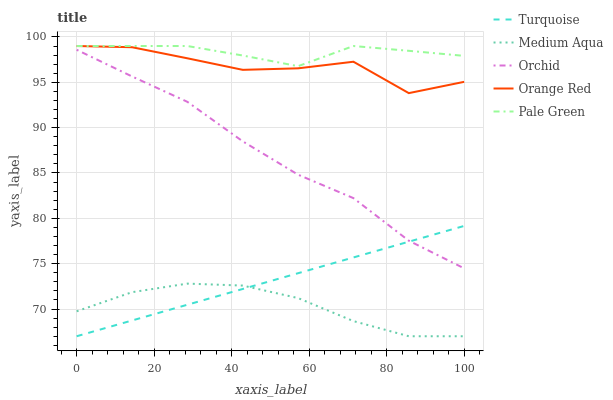Does Medium Aqua have the minimum area under the curve?
Answer yes or no. Yes. Does Pale Green have the maximum area under the curve?
Answer yes or no. Yes. Does Pale Green have the minimum area under the curve?
Answer yes or no. No. Does Medium Aqua have the maximum area under the curve?
Answer yes or no. No. Is Turquoise the smoothest?
Answer yes or no. Yes. Is Orange Red the roughest?
Answer yes or no. Yes. Is Pale Green the smoothest?
Answer yes or no. No. Is Pale Green the roughest?
Answer yes or no. No. Does Turquoise have the lowest value?
Answer yes or no. Yes. Does Pale Green have the lowest value?
Answer yes or no. No. Does Orange Red have the highest value?
Answer yes or no. Yes. Does Medium Aqua have the highest value?
Answer yes or no. No. Is Medium Aqua less than Orchid?
Answer yes or no. Yes. Is Pale Green greater than Turquoise?
Answer yes or no. Yes. Does Turquoise intersect Orchid?
Answer yes or no. Yes. Is Turquoise less than Orchid?
Answer yes or no. No. Is Turquoise greater than Orchid?
Answer yes or no. No. Does Medium Aqua intersect Orchid?
Answer yes or no. No. 